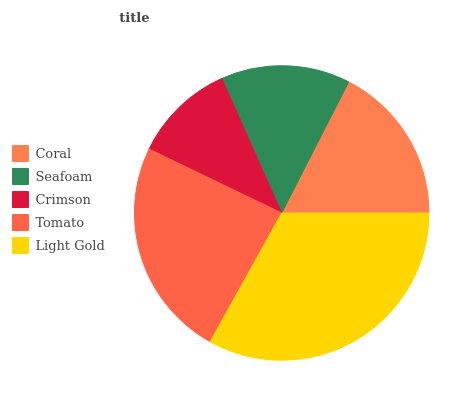Is Crimson the minimum?
Answer yes or no. Yes. Is Light Gold the maximum?
Answer yes or no. Yes. Is Seafoam the minimum?
Answer yes or no. No. Is Seafoam the maximum?
Answer yes or no. No. Is Coral greater than Seafoam?
Answer yes or no. Yes. Is Seafoam less than Coral?
Answer yes or no. Yes. Is Seafoam greater than Coral?
Answer yes or no. No. Is Coral less than Seafoam?
Answer yes or no. No. Is Coral the high median?
Answer yes or no. Yes. Is Coral the low median?
Answer yes or no. Yes. Is Seafoam the high median?
Answer yes or no. No. Is Light Gold the low median?
Answer yes or no. No. 